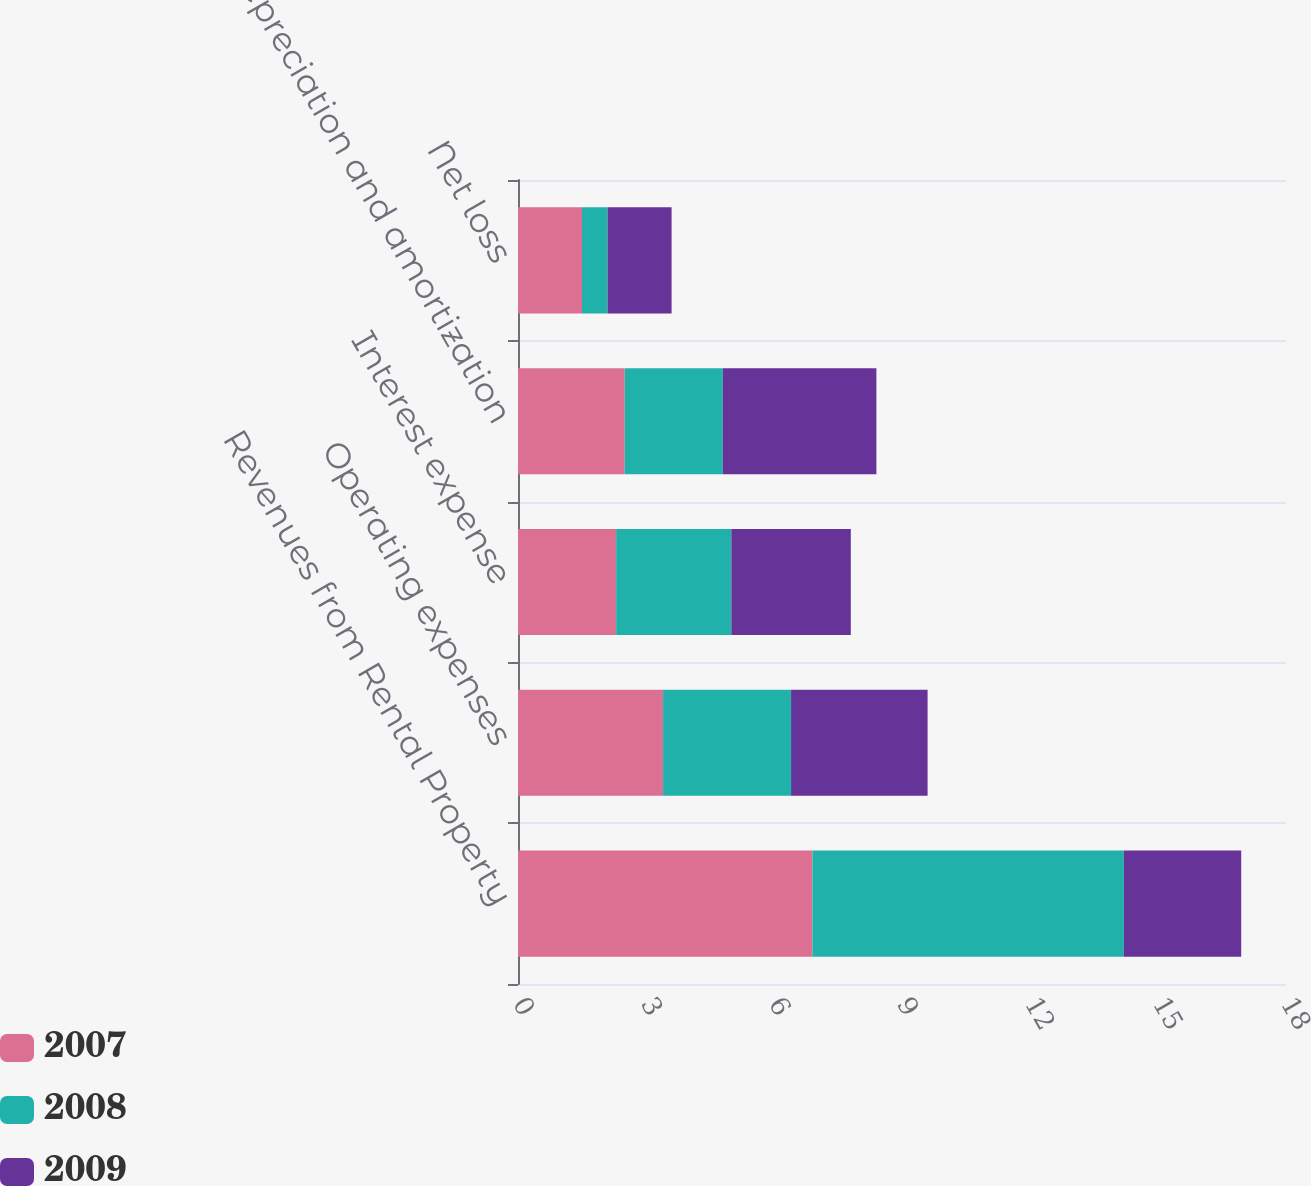Convert chart. <chart><loc_0><loc_0><loc_500><loc_500><stacked_bar_chart><ecel><fcel>Revenues from Rental Property<fcel>Operating expenses<fcel>Interest expense<fcel>Depreciation and amortization<fcel>Net loss<nl><fcel>2007<fcel>6.9<fcel>3.4<fcel>2.3<fcel>2.5<fcel>1.5<nl><fcel>2008<fcel>7.3<fcel>3<fcel>2.7<fcel>2.3<fcel>0.6<nl><fcel>2009<fcel>2.75<fcel>3.2<fcel>2.8<fcel>3.6<fcel>1.5<nl></chart> 